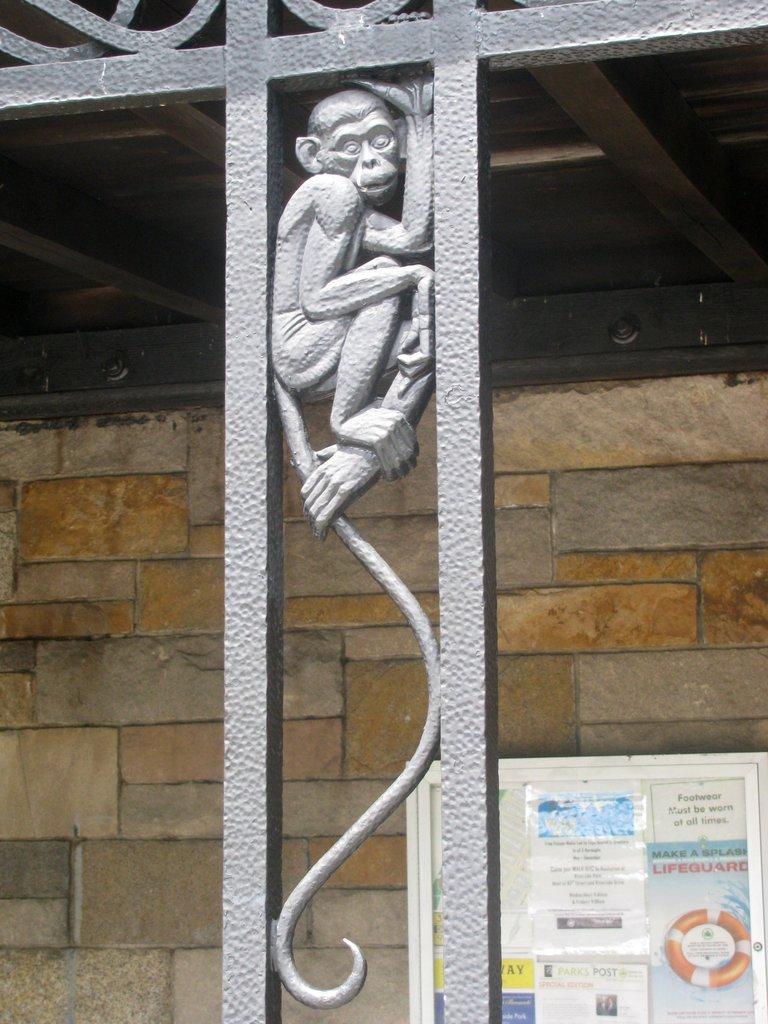Can you describe this image briefly? In the image in the center we can see one metal fence. And we can see one monkey sculpture in it. In the background there is a wall,roof and banner. 